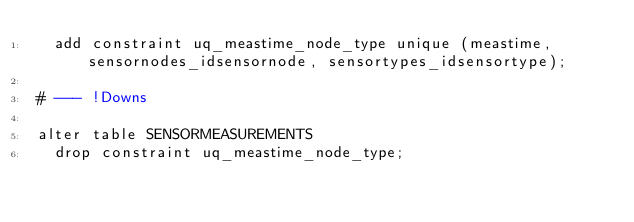<code> <loc_0><loc_0><loc_500><loc_500><_SQL_>  add constraint uq_meastime_node_type unique (meastime, sensornodes_idsensornode, sensortypes_idsensortype);

# --- !Downs

alter table SENSORMEASUREMENTS
  drop constraint uq_meastime_node_type;
</code> 